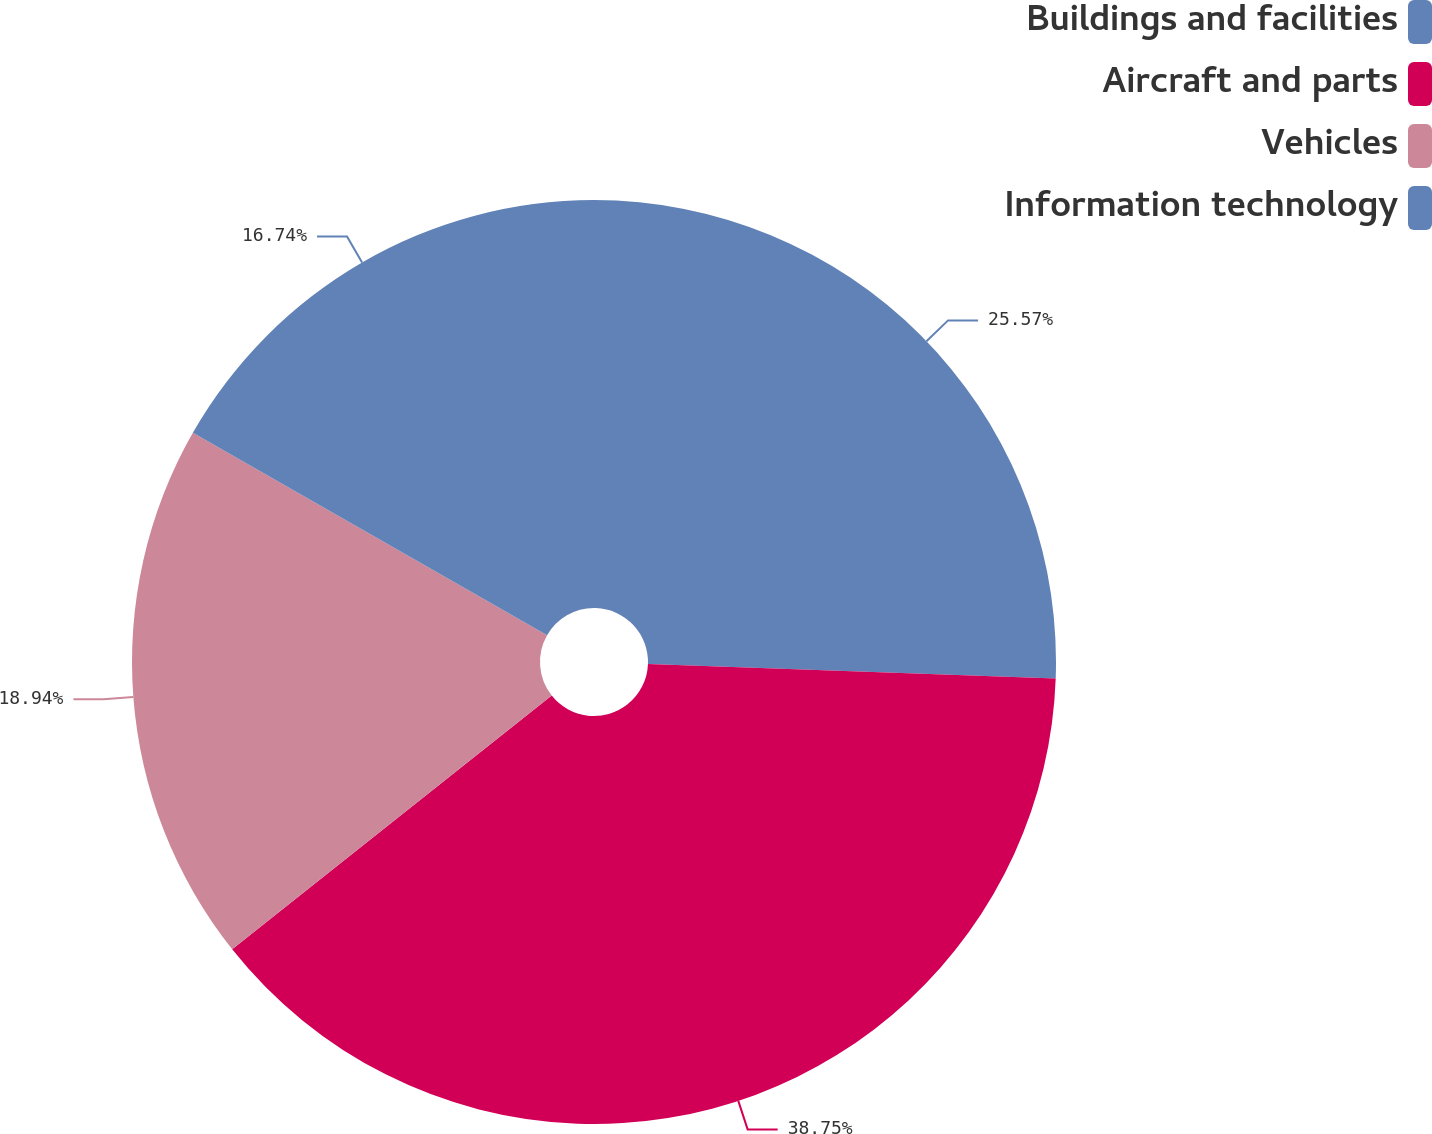Convert chart. <chart><loc_0><loc_0><loc_500><loc_500><pie_chart><fcel>Buildings and facilities<fcel>Aircraft and parts<fcel>Vehicles<fcel>Information technology<nl><fcel>25.57%<fcel>38.75%<fcel>18.94%<fcel>16.74%<nl></chart> 